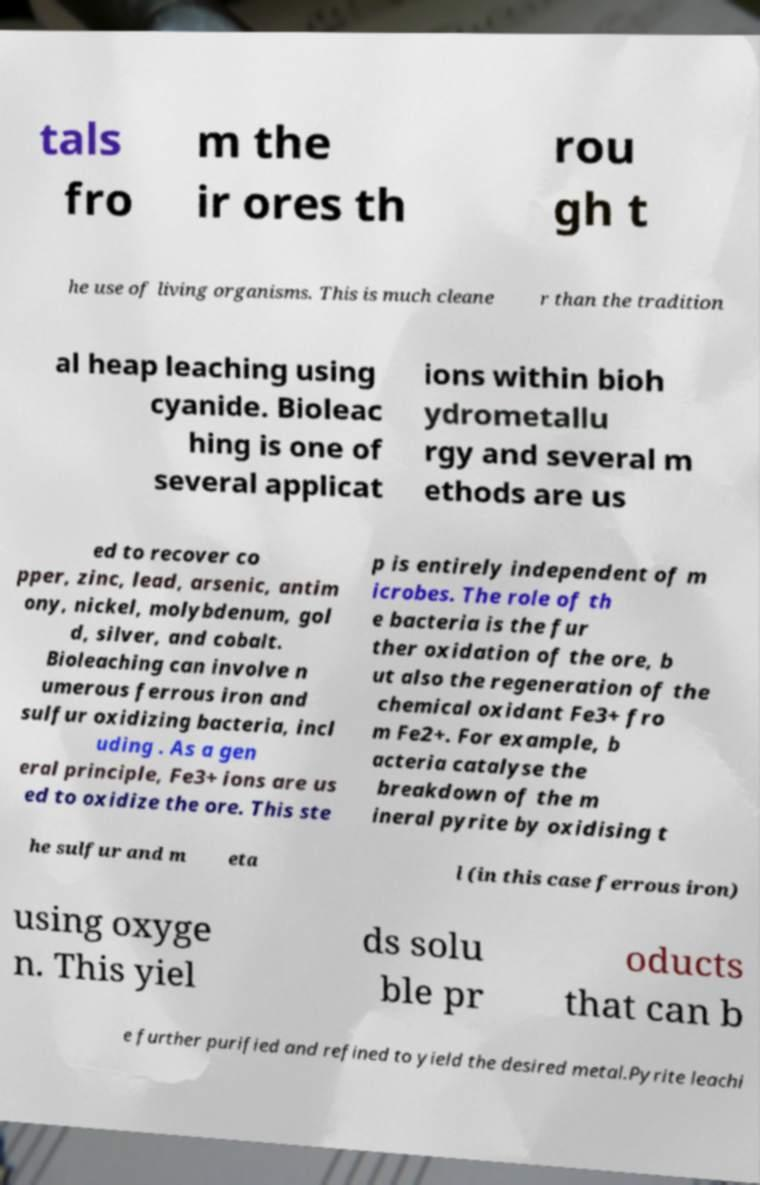Could you assist in decoding the text presented in this image and type it out clearly? tals fro m the ir ores th rou gh t he use of living organisms. This is much cleane r than the tradition al heap leaching using cyanide. Bioleac hing is one of several applicat ions within bioh ydrometallu rgy and several m ethods are us ed to recover co pper, zinc, lead, arsenic, antim ony, nickel, molybdenum, gol d, silver, and cobalt. Bioleaching can involve n umerous ferrous iron and sulfur oxidizing bacteria, incl uding . As a gen eral principle, Fe3+ ions are us ed to oxidize the ore. This ste p is entirely independent of m icrobes. The role of th e bacteria is the fur ther oxidation of the ore, b ut also the regeneration of the chemical oxidant Fe3+ fro m Fe2+. For example, b acteria catalyse the breakdown of the m ineral pyrite by oxidising t he sulfur and m eta l (in this case ferrous iron) using oxyge n. This yiel ds solu ble pr oducts that can b e further purified and refined to yield the desired metal.Pyrite leachi 